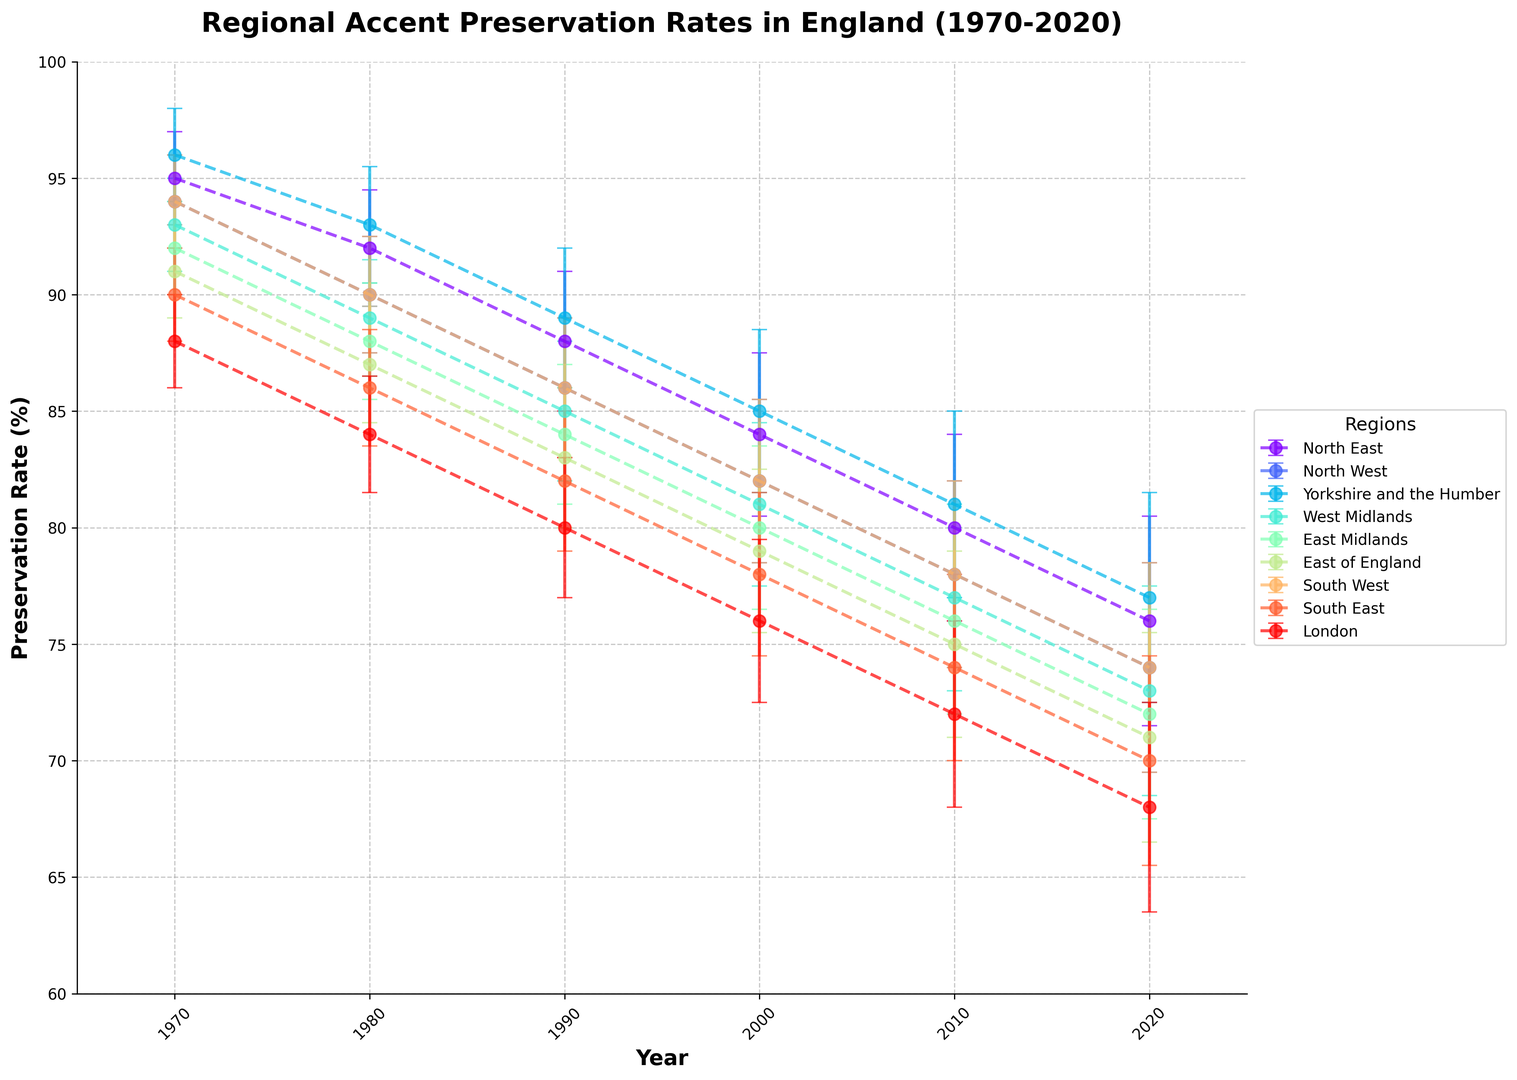Which region had the highest preservation rate in 1970? Looking at the plot, identify the region with the highest point in 1970. It is Yorkshire and the Humber with a preservation rate of 96%.
Answer: Yorkshire and the Humber How did the preservation rate in the North East change from 1970 to 2020? Observe the trend of the North East's line from 1970 (95%) to 2020 (76%). Calculate the difference: 95% - 76% = 19%.
Answer: Decreased by 19% Which region had the smallest error margin in 1990? Compare the error bars for all regions in 1990. Yorkshire and the Humber, West Midlands, North West, North East, East Midlands, East of England, South West, South East, and London all have an error margin of 3%.
Answer: All regions had the same smallest error margin of 3% Which two regions had the closest preservation rates in 2010? Inspect the rates in 2010. North East (80%), North West (78%), Yorkshire and the Humber (81%), West Midlands (77%), East Midlands (76%), East of England (75%), South West (78%), South East (74%), and London (72%). The pair with the smallest difference are East Midlands (76%) and East of England (75%).
Answer: East Midlands and East of England What is the average preservation rate for the North West across all years? Summarize the values for North West: (94, 90, 86, 82, 78, 74). Calculate the average: (94 + 90 + 86 + 82 + 78 + 74) / 6 = 84.
Answer: 84 What is the overall trend in preservation rates for all regions? Observe the general direction of the lines for all regions from 1970 to 2020. All regions show a consistent downward trend.
Answer: Downward trend Which region experienced the largest decline in preservation rate from 1970 to 2020? Calculate the difference for each region from 1970 to 2020: North East (95-76=19), North West (94-74=20), Yorkshire and the Humber (96-77=19), West Midlands (93-73=20), East Midlands (92-72=20), East of England (91-71=20), South West (94-74=20), South East (90-70=20), London (88-68=20). Multiple regions experienced a decline of 20.
Answer: North West, West Midlands, East Midlands, East of England, South West, South East, London What is the difference in preservation rate between London and Yorkshire and the Humber in 2020? Check the 2020 rates: London (68%) and Yorkshire and the Humber (77%), then calculate the difference: 77% - 68% = 9%.
Answer: 9% Between the South East and South West, which had a higher preservation rate in 1990? Observe 1990 rates for South East (82%) and South West (86%). The South West has a higher rate.
Answer: South West 